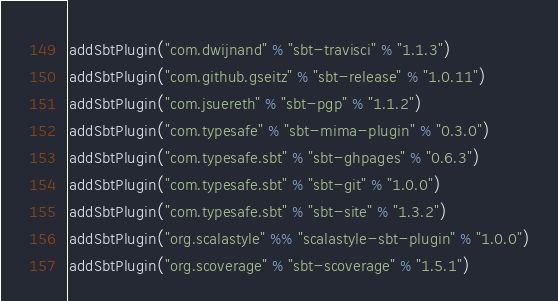Convert code to text. <code><loc_0><loc_0><loc_500><loc_500><_Scala_>addSbtPlugin("com.dwijnand" % "sbt-travisci" % "1.1.3")
addSbtPlugin("com.github.gseitz" % "sbt-release" % "1.0.11")
addSbtPlugin("com.jsuereth" % "sbt-pgp" % "1.1.2")
addSbtPlugin("com.typesafe" % "sbt-mima-plugin" % "0.3.0")
addSbtPlugin("com.typesafe.sbt" % "sbt-ghpages" % "0.6.3")
addSbtPlugin("com.typesafe.sbt" % "sbt-git" % "1.0.0")
addSbtPlugin("com.typesafe.sbt" % "sbt-site" % "1.3.2")
addSbtPlugin("org.scalastyle" %% "scalastyle-sbt-plugin" % "1.0.0")
addSbtPlugin("org.scoverage" % "sbt-scoverage" % "1.5.1")
</code> 